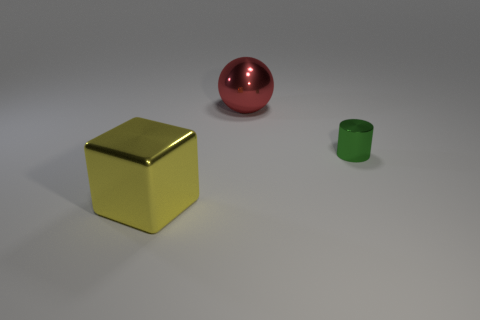What number of large red objects are there?
Provide a succinct answer. 1. What number of objects are large yellow cubes or yellow rubber cylinders?
Keep it short and to the point. 1. Are there any red balls to the right of the big red metallic sphere?
Your answer should be compact. No. Is the number of green cylinders that are right of the block greater than the number of big red things that are on the right side of the small metal cylinder?
Your response must be concise. Yes. What number of spheres are big metallic things or small green matte objects?
Keep it short and to the point. 1. Is the number of large red metal spheres that are left of the green metal cylinder less than the number of metallic things behind the large yellow thing?
Your response must be concise. Yes. How many things are either objects left of the tiny green shiny object or yellow shiny things?
Your answer should be compact. 2. There is a object on the left side of the big shiny thing that is on the right side of the shiny block; what shape is it?
Ensure brevity in your answer.  Cube. Are there any red things of the same size as the yellow metallic thing?
Offer a very short reply. Yes. Is the number of red metal things greater than the number of large green shiny balls?
Provide a short and direct response. Yes. 